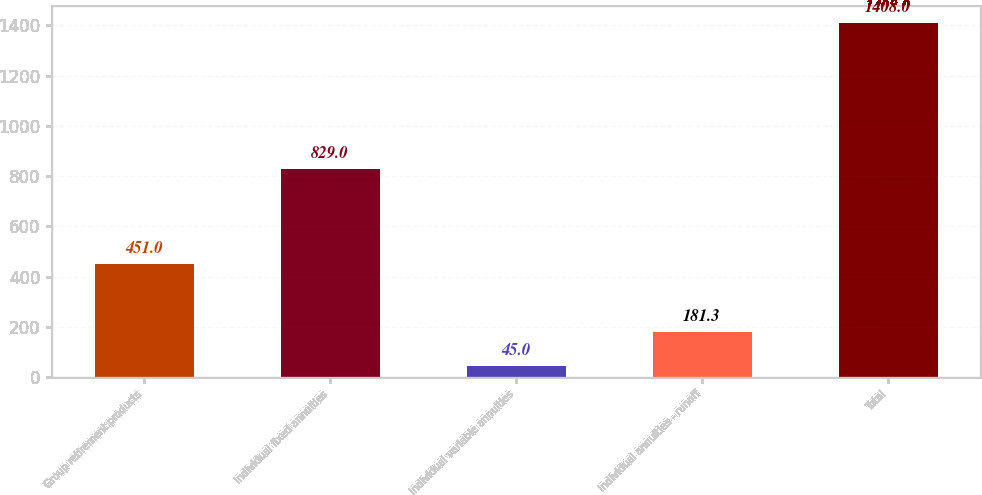Convert chart. <chart><loc_0><loc_0><loc_500><loc_500><bar_chart><fcel>Group retirement products<fcel>Individual fixed annuities<fcel>Individual variable annuities<fcel>Individual annuities - runoff<fcel>Total<nl><fcel>451<fcel>829<fcel>45<fcel>181.3<fcel>1408<nl></chart> 